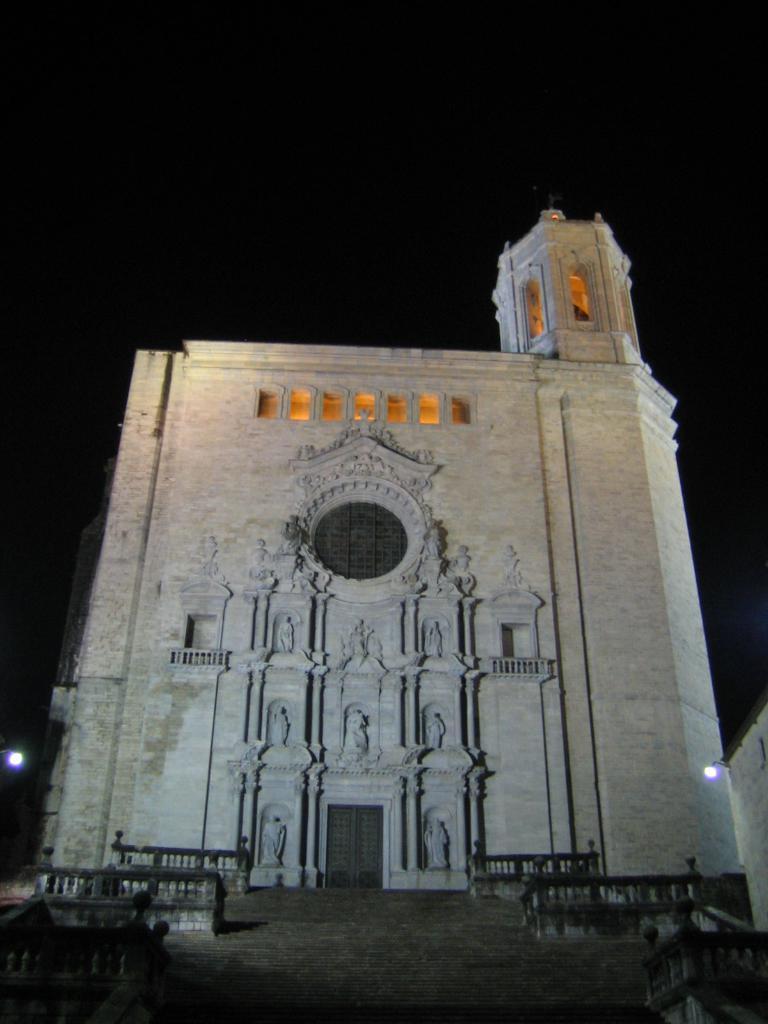Could you give a brief overview of what you see in this image? In the picture I can see a building and street lights. In the background I can see the sky. Here I can see steps and some other objects. 